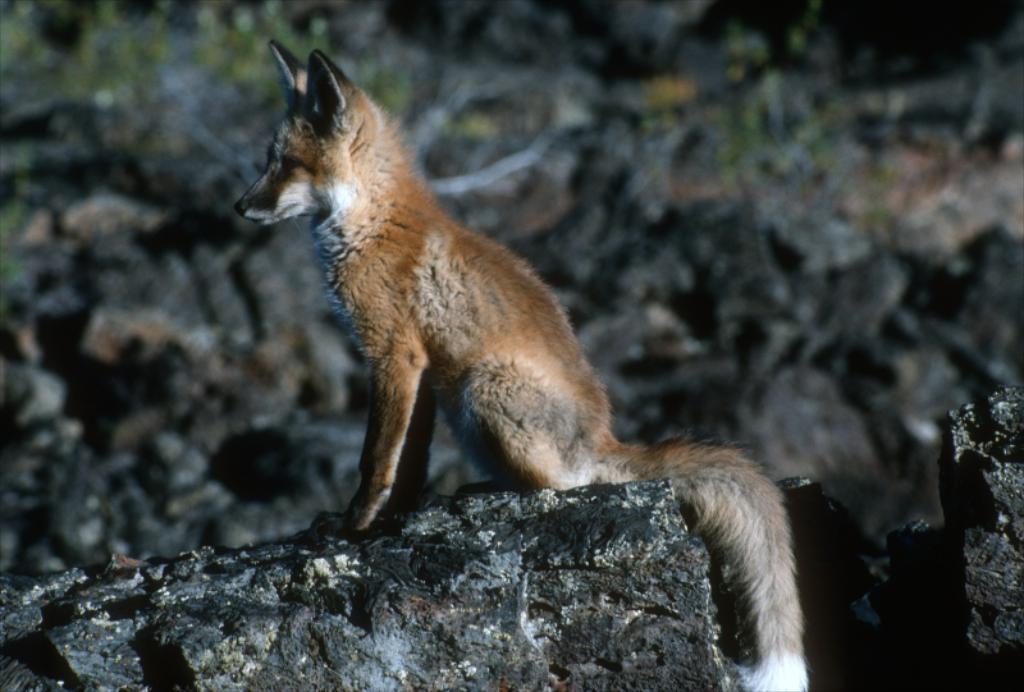Describe this image in one or two sentences. In this image I can see an animal and the animal is in brown and white color and I can see few rocks. 